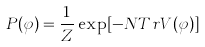<formula> <loc_0><loc_0><loc_500><loc_500>P ( \varphi ) = { \frac { 1 } { Z } } \exp [ - N T r V ( \varphi ) ]</formula> 